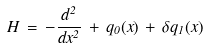Convert formula to latex. <formula><loc_0><loc_0><loc_500><loc_500>H \, = \, - \frac { d ^ { 2 } } { d x ^ { 2 } } \, + \, q _ { 0 } ( x ) \, + \, \delta q _ { 1 } ( x )</formula> 